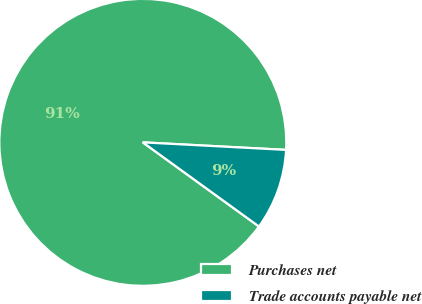<chart> <loc_0><loc_0><loc_500><loc_500><pie_chart><fcel>Purchases net<fcel>Trade accounts payable net<nl><fcel>90.86%<fcel>9.14%<nl></chart> 